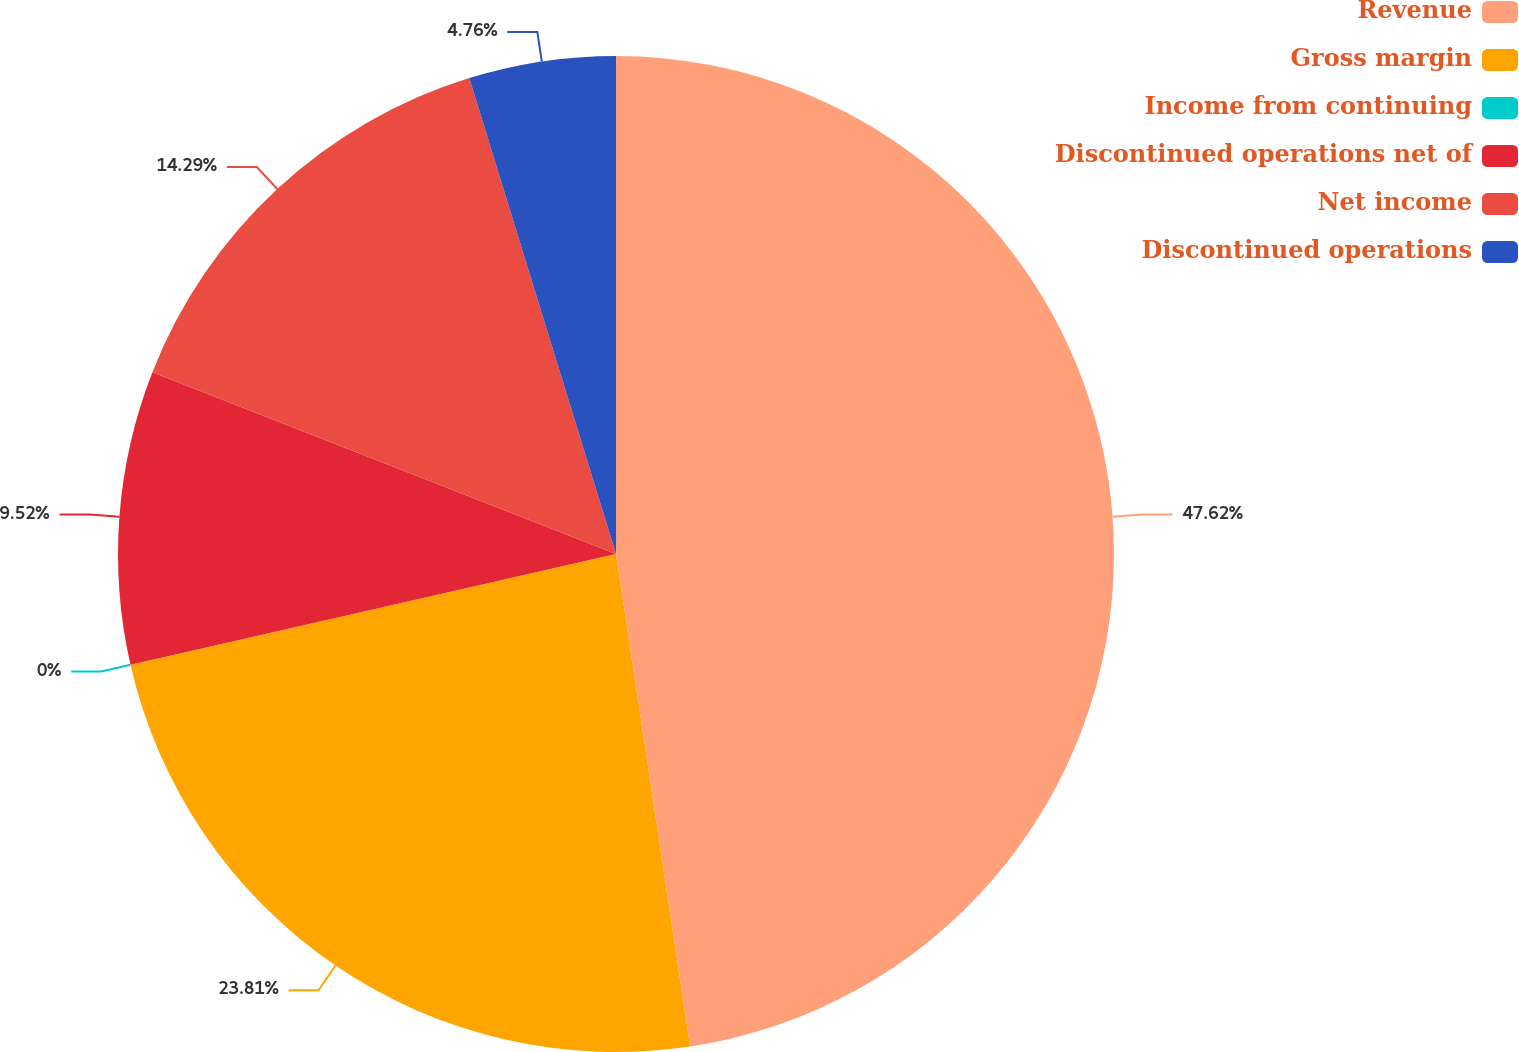<chart> <loc_0><loc_0><loc_500><loc_500><pie_chart><fcel>Revenue<fcel>Gross margin<fcel>Income from continuing<fcel>Discontinued operations net of<fcel>Net income<fcel>Discontinued operations<nl><fcel>47.62%<fcel>23.81%<fcel>0.0%<fcel>9.52%<fcel>14.29%<fcel>4.76%<nl></chart> 